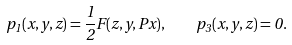Convert formula to latex. <formula><loc_0><loc_0><loc_500><loc_500>p _ { 1 } ( x , y , z ) = \frac { 1 } { 2 } F ( z , y , P x ) , \quad p _ { 3 } ( x , y , z ) = 0 .</formula> 